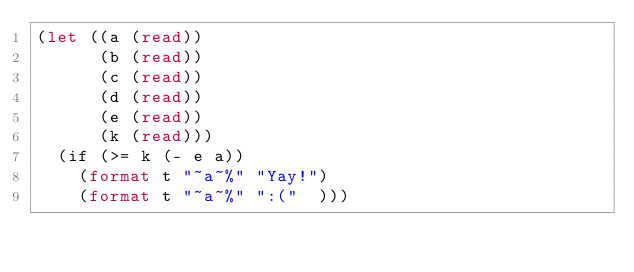Convert code to text. <code><loc_0><loc_0><loc_500><loc_500><_Lisp_>(let ((a (read))
      (b (read))
      (c (read))
      (d (read))
      (e (read))
      (k (read)))
  (if (>= k (- e a))
    (format t "~a~%" "Yay!")
    (format t "~a~%" ":("  )))
</code> 